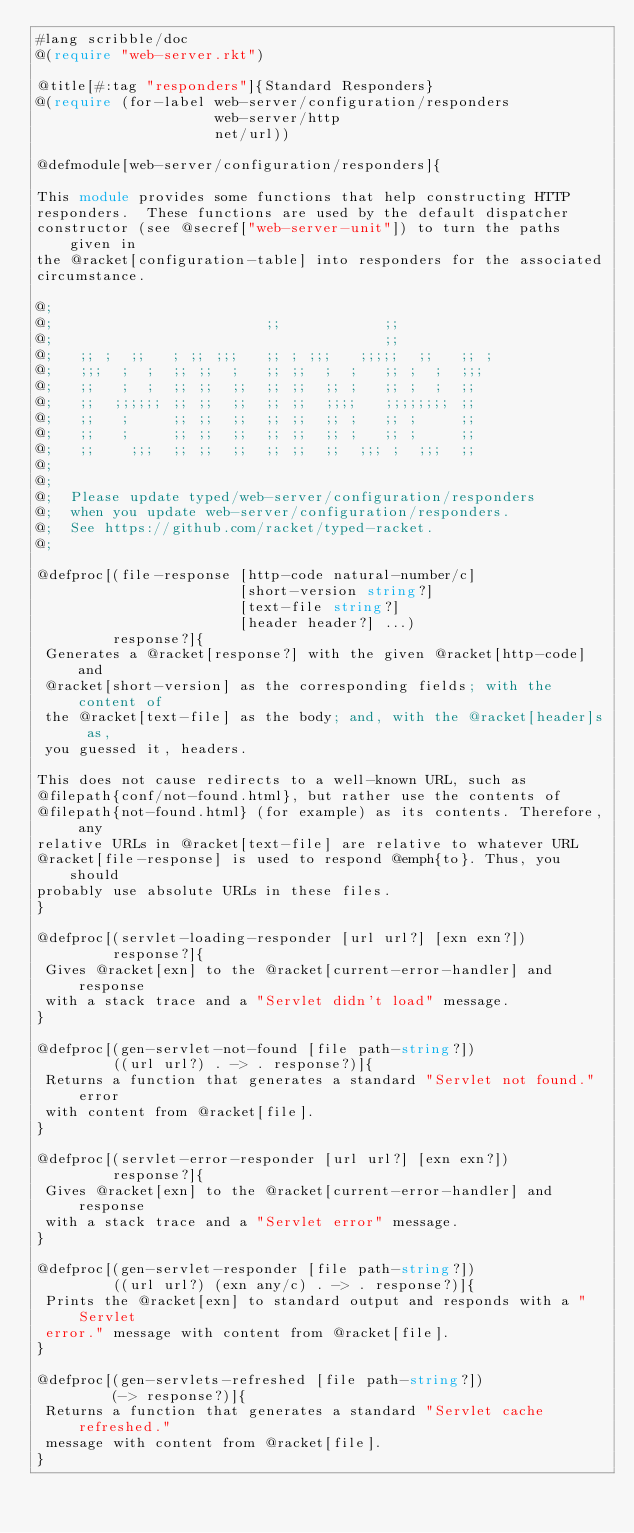<code> <loc_0><loc_0><loc_500><loc_500><_Racket_>#lang scribble/doc
@(require "web-server.rkt")

@title[#:tag "responders"]{Standard Responders}
@(require (for-label web-server/configuration/responders
                     web-server/http
                     net/url))

@defmodule[web-server/configuration/responders]{

This module provides some functions that help constructing HTTP
responders.  These functions are used by the default dispatcher
constructor (see @secref["web-server-unit"]) to turn the paths given in
the @racket[configuration-table] into responders for the associated
circumstance.

@;
@;                         ;;            ;;
@;                                       ;;
@;   ;; ;  ;;   ; ;; ;;;   ;; ; ;;;   ;;;;;  ;;   ;; ;
@;   ;;;  ;  ;  ;; ;;  ;   ;; ;;  ;  ;   ;; ;  ;  ;;;
@;   ;;   ;  ;  ;; ;;  ;;  ;; ;;  ;; ;   ;; ;  ;  ;;
@;   ;;  ;;;;;; ;; ;;  ;;  ;; ;;  ;;;;   ;;;;;;;; ;;
@;   ;;   ;     ;; ;;  ;;  ;; ;;  ;; ;   ;; ;     ;;
@;   ;;   ;     ;; ;;  ;;  ;; ;;  ;; ;   ;; ;     ;;
@;   ;;    ;;;  ;; ;;  ;;  ;; ;;  ;;  ;;; ;  ;;;  ;;
@;
@;
@;  Please update typed/web-server/configuration/responders
@;  when you update web-server/configuration/responders.
@;  See https://github.com/racket/typed-racket.
@;

@defproc[(file-response [http-code natural-number/c]
                        [short-version string?]
                        [text-file string?]
                        [header header?] ...)
         response?]{
 Generates a @racket[response?] with the given @racket[http-code] and
 @racket[short-version] as the corresponding fields; with the content of
 the @racket[text-file] as the body; and, with the @racket[header]s as,
 you guessed it, headers.

This does not cause redirects to a well-known URL, such as
@filepath{conf/not-found.html}, but rather use the contents of
@filepath{not-found.html} (for example) as its contents. Therefore, any
relative URLs in @racket[text-file] are relative to whatever URL
@racket[file-response] is used to respond @emph{to}. Thus, you should
probably use absolute URLs in these files.
}

@defproc[(servlet-loading-responder [url url?] [exn exn?])
         response?]{
 Gives @racket[exn] to the @racket[current-error-handler] and response
 with a stack trace and a "Servlet didn't load" message.
}

@defproc[(gen-servlet-not-found [file path-string?])
         ((url url?) . -> . response?)]{
 Returns a function that generates a standard "Servlet not found." error
 with content from @racket[file].
}

@defproc[(servlet-error-responder [url url?] [exn exn?])
         response?]{
 Gives @racket[exn] to the @racket[current-error-handler] and response
 with a stack trace and a "Servlet error" message.
}

@defproc[(gen-servlet-responder [file path-string?])
         ((url url?) (exn any/c) . -> . response?)]{
 Prints the @racket[exn] to standard output and responds with a "Servlet
 error." message with content from @racket[file].
}

@defproc[(gen-servlets-refreshed [file path-string?])
         (-> response?)]{
 Returns a function that generates a standard "Servlet cache refreshed."
 message with content from @racket[file].
}
</code> 